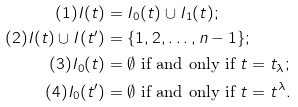Convert formula to latex. <formula><loc_0><loc_0><loc_500><loc_500>( 1 ) I ( t ) & = I _ { 0 } ( t ) \cup I _ { 1 } ( t ) ; \\ ( 2 ) { I ( t ) \cup I ( t ^ { \prime } ) } & = \{ 1 , 2 , \dots , n - 1 \} ; \\ ( 3 ) I _ { 0 } ( t ) & = \emptyset \text { if and only if $t=t_{\lambda}$} ; \\ ( 4 ) I _ { 0 } ( t ^ { \prime } ) & = \text {$\emptyset$ if and only if $t=t^{\lambda}$} .</formula> 